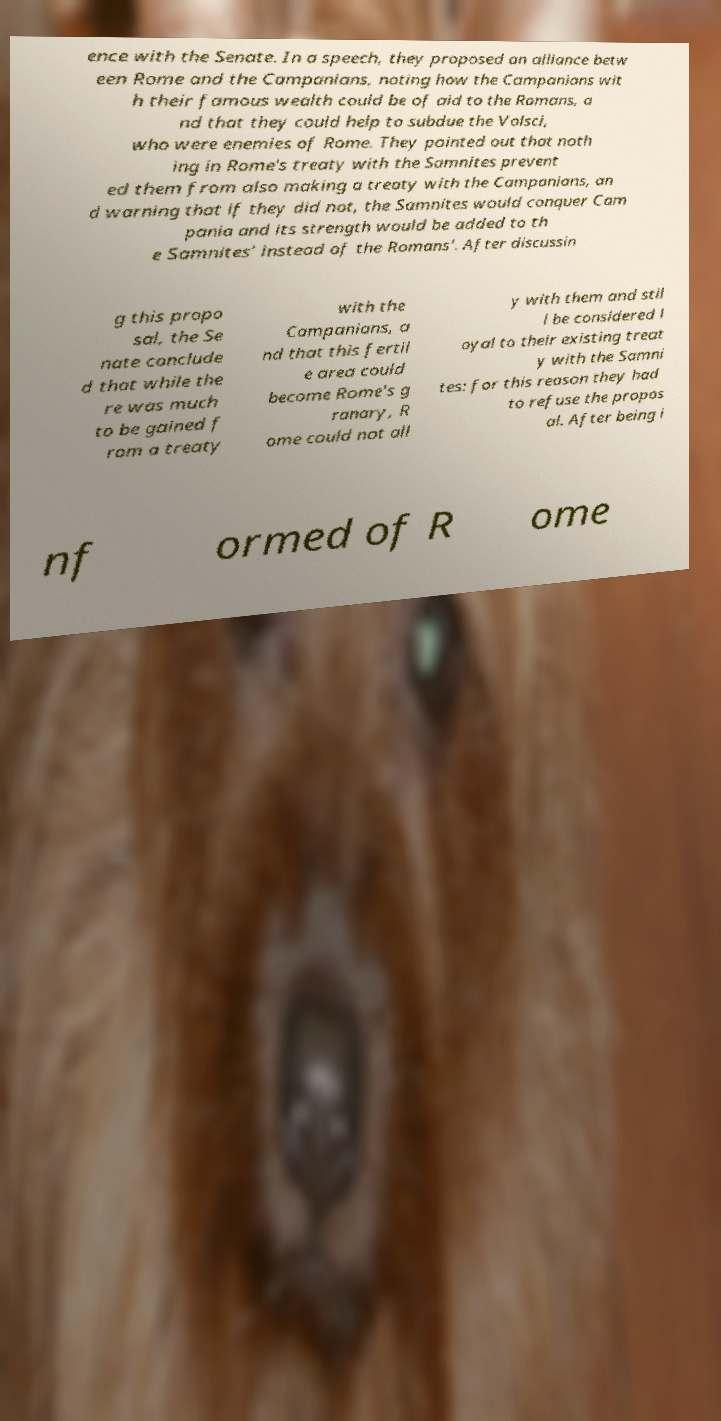There's text embedded in this image that I need extracted. Can you transcribe it verbatim? ence with the Senate. In a speech, they proposed an alliance betw een Rome and the Campanians, noting how the Campanians wit h their famous wealth could be of aid to the Romans, a nd that they could help to subdue the Volsci, who were enemies of Rome. They pointed out that noth ing in Rome's treaty with the Samnites prevent ed them from also making a treaty with the Campanians, an d warning that if they did not, the Samnites would conquer Cam pania and its strength would be added to th e Samnites' instead of the Romans'. After discussin g this propo sal, the Se nate conclude d that while the re was much to be gained f rom a treaty with the Campanians, a nd that this fertil e area could become Rome's g ranary, R ome could not all y with them and stil l be considered l oyal to their existing treat y with the Samni tes: for this reason they had to refuse the propos al. After being i nf ormed of R ome 